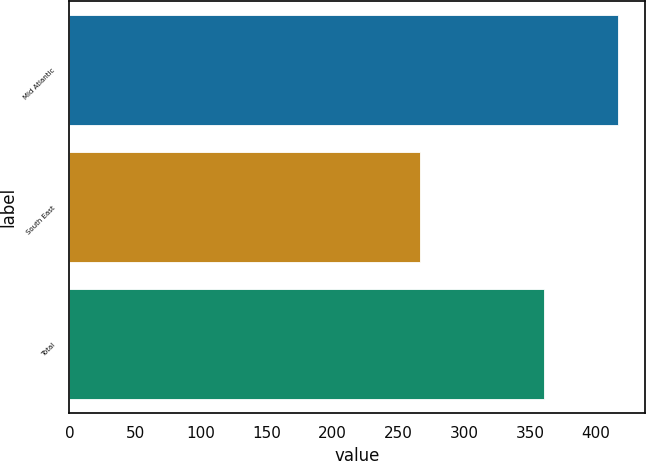<chart> <loc_0><loc_0><loc_500><loc_500><bar_chart><fcel>Mid Atlantic<fcel>South East<fcel>Total<nl><fcel>416.7<fcel>265.9<fcel>360.4<nl></chart> 